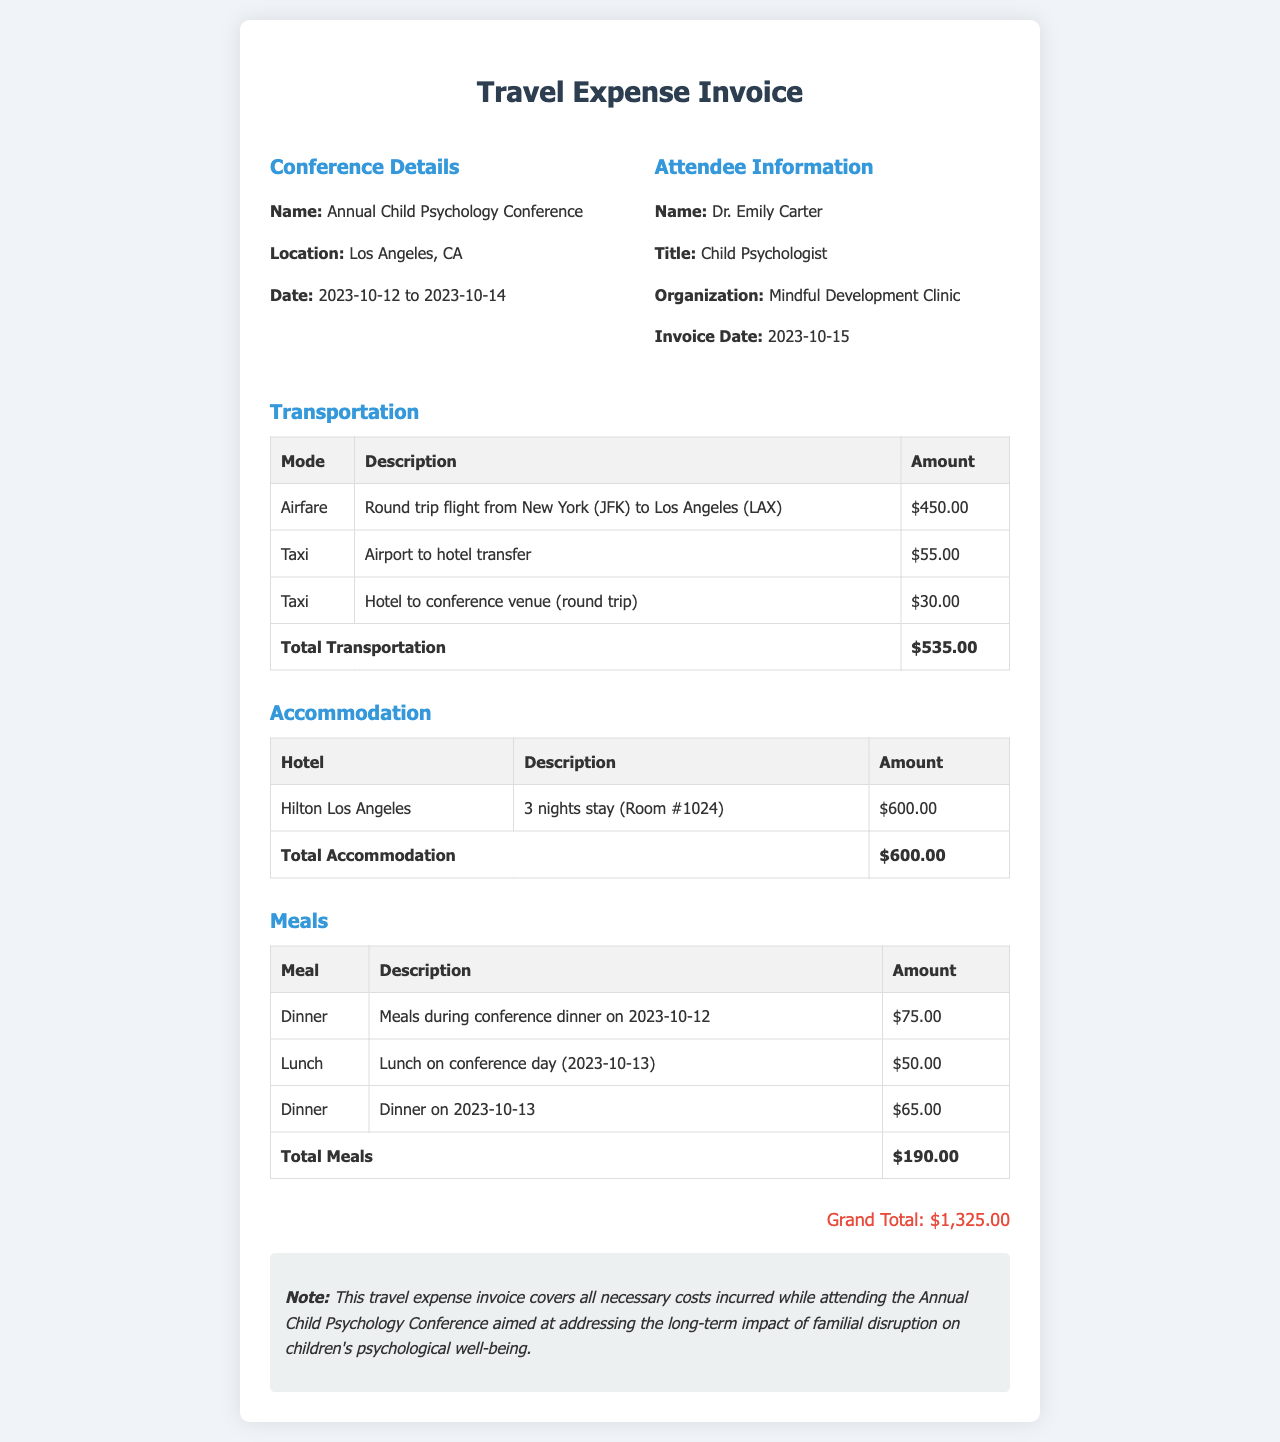What is the name of the conference? The name of the conference is mentioned in the document as "Annual Child Psychology Conference."
Answer: Annual Child Psychology Conference Who is the attendee? The document specifies the attendee's name as "Dr. Emily Carter."
Answer: Dr. Emily Carter What is the total amount for transportation? The invoice provides a total for transportation expenses of $535.00.
Answer: $535.00 How many nights was the accommodation booked for? The accommodation section indicates a stay of "3 nights."
Answer: 3 nights What is the grand total of the expenses? The grand total is listed at the end of the invoice as "$1,325.00."
Answer: $1,325.00 Which hotel was the accommodation at? The document specifies the hotel as "Hilton Los Angeles."
Answer: Hilton Los Angeles What type of meal was served on 2023-10-12? The invoice indicates that dinner was served on that date.
Answer: Dinner How much was the taxi for the airport to hotel transfer? The specific taxi amount for the airport to hotel transfer is $55.00.
Answer: $55.00 What is the invoice date? The document states that the invoice date is "2023-10-15."
Answer: 2023-10-15 